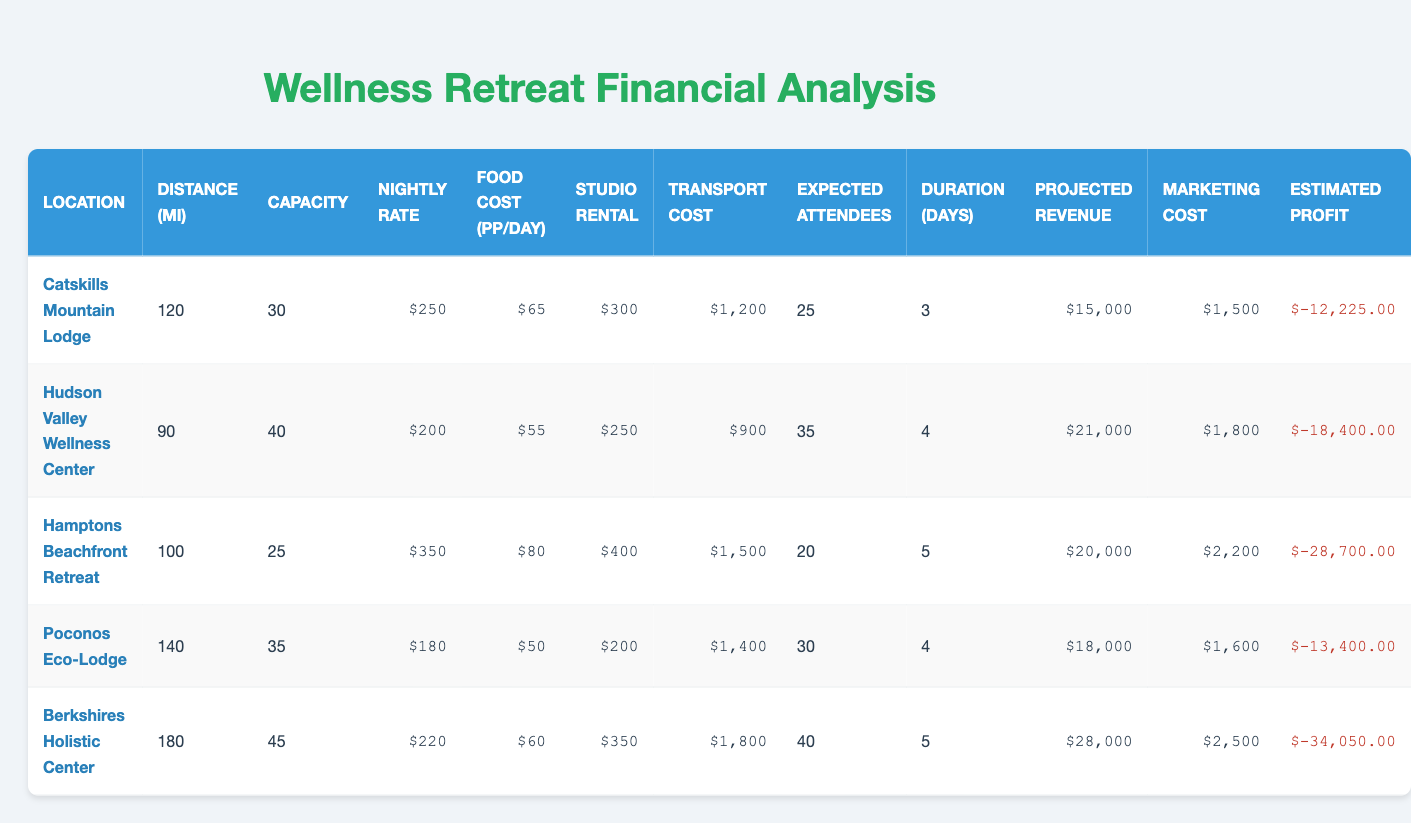What is the projected revenue for the Hudson Valley Wellness Center? The projected revenue for the Hudson Valley Wellness Center can be found directly in the table. It states $21,000.
Answer: $21,000 How much is the marketing cost for the Catskills Mountain Lodge? Looking at the table, the marketing cost for the Catskills Mountain Lodge is explicitly listed as $1,500.
Answer: $1,500 What is the total expected profit for the Poconos Eco-Lodge? For the Poconos Eco-Lodge, the projected revenue is $18,000 and the total costs (nightly rate, food costs, studio rental, transport cost, and marketing) total $14,600, resulting in a profit of $3,400 when subtracting total costs from revenue.
Answer: $3,400 Which location has the highest estimated profit? By comparing the estimated profits listed for each location, Berksire Holistic Center has the highest profit of $5,350, as detailed in the table.
Answer: Berkshires Holistic Center Is the capacity of the Hamptons Beachfront Retreat greater than the capacity of the Poconos Eco-Lodge? The capacity of Hamptons Beachfront Retreat is 25, while the Poconos Eco-Lodge has a capacity of 35. Therefore, the capacity of the Hamptons Beachfront Retreat is not greater.
Answer: No What is the average nightly rate for all locations? To find the average nightly rate, sum all the nightly rates ($250 + $200 + $350 + $180 + $220 = $1,180) and divide by the number of locations (5). The average nightly rate is $1,180 / 5 = $236.
Answer: $236 Which retreat offers the best profit margin based on the number of expected attendees? To determine the best profit margin based on expected attendees, calculate the profit per expected attendee for each location. For example, the Berkshires Holistic Center's profit is $5,350 divided by 40 attendees, yielding $133.75 per attendee, which is the highest among all options.
Answer: Berkshires Holistic Center Is the total cost for the Catskills Mountain Lodge higher than the Hamptons Beachfront Retreat? For the Catskills Mountain Lodge, the total cost is $13,575 calculated from various costs, while the Hamptons Beachfront Retreat has a total cost of $21,500. The Catskills cost is not higher.
Answer: No What is the difference in total estimated profit between the Hudson Valley Wellness Center and the Catskills Mountain Lodge? The profit for Hudson Valley Wellness Center is $4,050, and for Catskills Mountain Lodge, it is $1,425. The difference is $4,050 - $1,425 = $2,625.
Answer: $2,625 